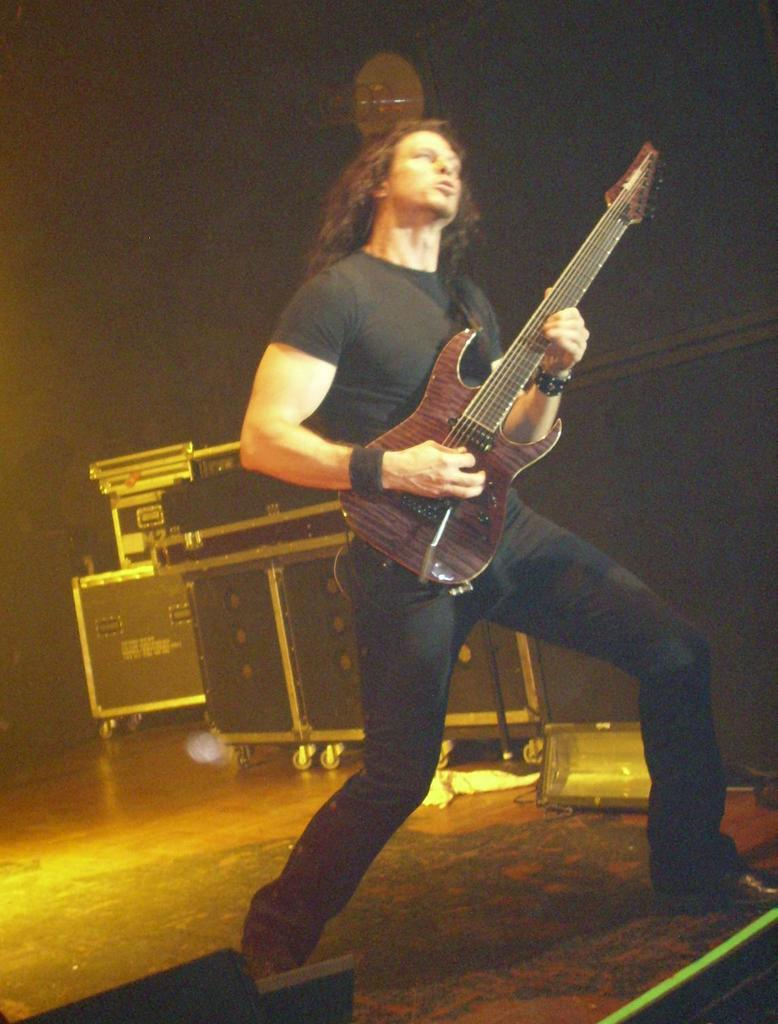What is the main subject of the image? The main subject of the image is a man. What is the man doing in the image? The man is standing and holding a guitar. What can be seen beneath the man's feet in the image? The floor is visible in the image. How would you describe the lighting in the image? The background of the image is a bit dark. What type of apple can be seen on the engine in the image? There is no apple or engine present in the image. How does friction affect the guitar strings in the image? The image does not show the guitar strings in motion, so it is not possible to determine the effect of friction on them. 